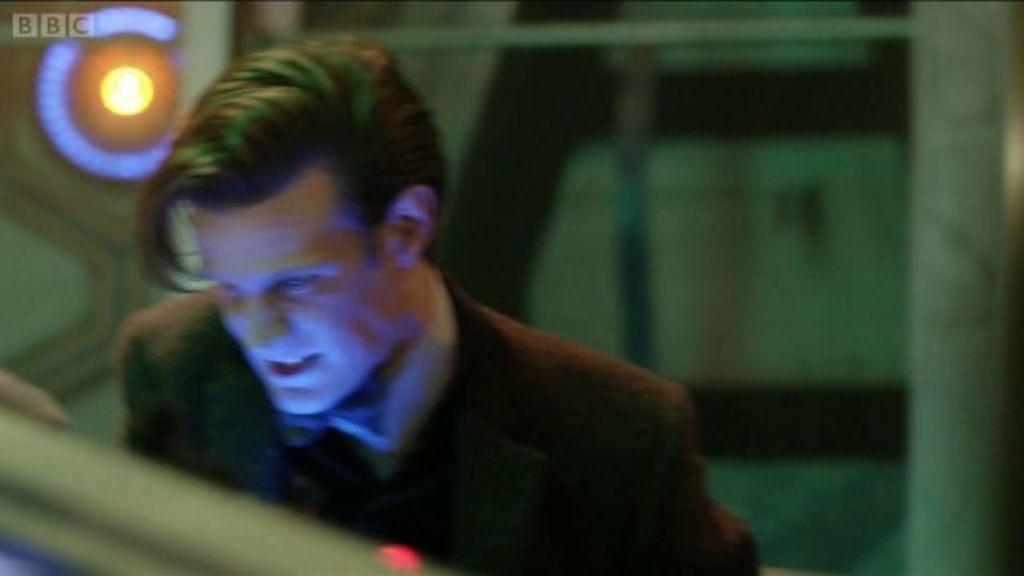Describe this image in one or two sentences. In this image there is a man standing wearing suit. In the background we can see a light. 